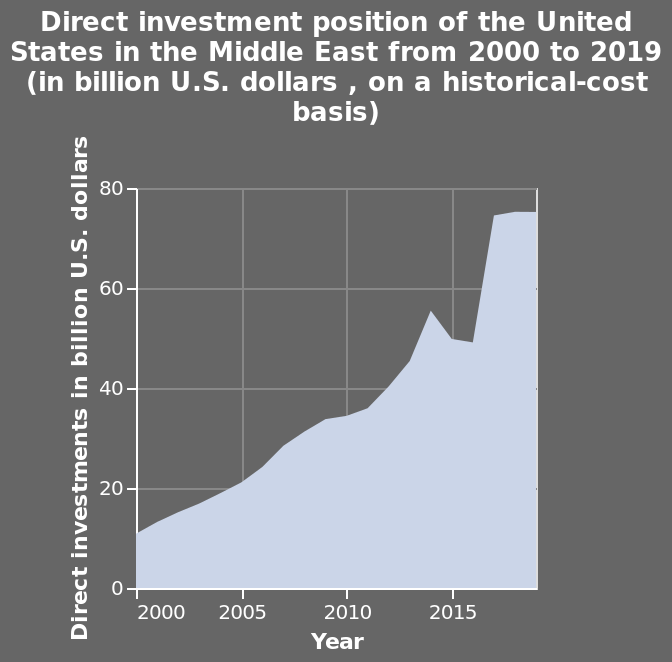<image>
please describe the details of the chart Direct investment position of the United States in the Middle East from 2000 to 2019 (in billion U.S. dollars , on a historical-cost basis) is a area chart. The x-axis plots Year on linear scale with a minimum of 2000 and a maximum of 2015 while the y-axis shows Direct investments in billion U.S. dollars using linear scale of range 0 to 80. Is the line chart for the indirect investment position of the United States in the Middle East from 2000 to 2019 (in billion U.S. dollars, on a historical-cost basis) plotted on a logarithmic scale for the x-axis with a minimum of 2000 and a maximum of 2015, while the y-axis shows indirect investments in billion U.S. dollars using a linear scale of range 0 to 100? No.Direct investment position of the United States in the Middle East from 2000 to 2019 (in billion U.S. dollars , on a historical-cost basis) is a area chart. The x-axis plots Year on linear scale with a minimum of 2000 and a maximum of 2015 while the y-axis shows Direct investments in billion U.S. dollars using linear scale of range 0 to 80. 